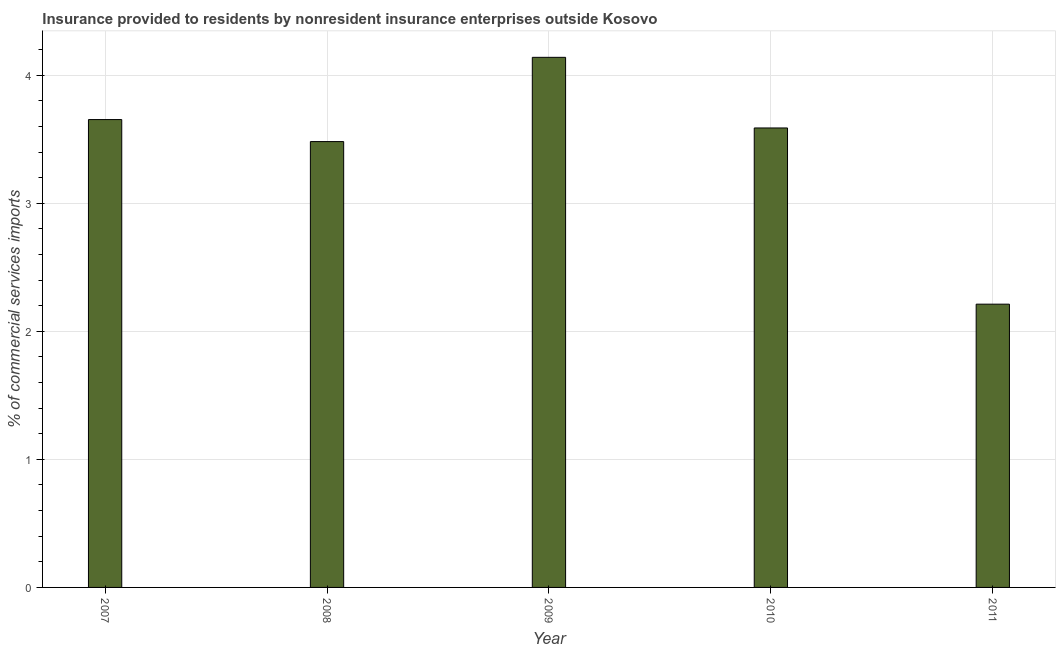Does the graph contain any zero values?
Offer a terse response. No. Does the graph contain grids?
Keep it short and to the point. Yes. What is the title of the graph?
Your response must be concise. Insurance provided to residents by nonresident insurance enterprises outside Kosovo. What is the label or title of the X-axis?
Make the answer very short. Year. What is the label or title of the Y-axis?
Offer a terse response. % of commercial services imports. What is the insurance provided by non-residents in 2010?
Your response must be concise. 3.59. Across all years, what is the maximum insurance provided by non-residents?
Keep it short and to the point. 4.14. Across all years, what is the minimum insurance provided by non-residents?
Ensure brevity in your answer.  2.21. What is the sum of the insurance provided by non-residents?
Your answer should be very brief. 17.07. What is the difference between the insurance provided by non-residents in 2008 and 2010?
Offer a very short reply. -0.11. What is the average insurance provided by non-residents per year?
Make the answer very short. 3.42. What is the median insurance provided by non-residents?
Make the answer very short. 3.59. What is the ratio of the insurance provided by non-residents in 2008 to that in 2010?
Ensure brevity in your answer.  0.97. What is the difference between the highest and the second highest insurance provided by non-residents?
Provide a short and direct response. 0.49. What is the difference between the highest and the lowest insurance provided by non-residents?
Keep it short and to the point. 1.93. In how many years, is the insurance provided by non-residents greater than the average insurance provided by non-residents taken over all years?
Ensure brevity in your answer.  4. How many bars are there?
Provide a succinct answer. 5. How many years are there in the graph?
Your answer should be compact. 5. What is the difference between two consecutive major ticks on the Y-axis?
Make the answer very short. 1. What is the % of commercial services imports in 2007?
Your answer should be very brief. 3.65. What is the % of commercial services imports of 2008?
Provide a succinct answer. 3.48. What is the % of commercial services imports in 2009?
Offer a very short reply. 4.14. What is the % of commercial services imports in 2010?
Your answer should be compact. 3.59. What is the % of commercial services imports of 2011?
Provide a short and direct response. 2.21. What is the difference between the % of commercial services imports in 2007 and 2008?
Offer a terse response. 0.17. What is the difference between the % of commercial services imports in 2007 and 2009?
Ensure brevity in your answer.  -0.49. What is the difference between the % of commercial services imports in 2007 and 2010?
Give a very brief answer. 0.07. What is the difference between the % of commercial services imports in 2007 and 2011?
Offer a very short reply. 1.44. What is the difference between the % of commercial services imports in 2008 and 2009?
Keep it short and to the point. -0.66. What is the difference between the % of commercial services imports in 2008 and 2010?
Your answer should be very brief. -0.11. What is the difference between the % of commercial services imports in 2008 and 2011?
Provide a short and direct response. 1.27. What is the difference between the % of commercial services imports in 2009 and 2010?
Offer a very short reply. 0.55. What is the difference between the % of commercial services imports in 2009 and 2011?
Your response must be concise. 1.93. What is the difference between the % of commercial services imports in 2010 and 2011?
Give a very brief answer. 1.38. What is the ratio of the % of commercial services imports in 2007 to that in 2008?
Make the answer very short. 1.05. What is the ratio of the % of commercial services imports in 2007 to that in 2009?
Your answer should be compact. 0.88. What is the ratio of the % of commercial services imports in 2007 to that in 2010?
Make the answer very short. 1.02. What is the ratio of the % of commercial services imports in 2007 to that in 2011?
Offer a very short reply. 1.65. What is the ratio of the % of commercial services imports in 2008 to that in 2009?
Offer a terse response. 0.84. What is the ratio of the % of commercial services imports in 2008 to that in 2011?
Your answer should be compact. 1.57. What is the ratio of the % of commercial services imports in 2009 to that in 2010?
Make the answer very short. 1.15. What is the ratio of the % of commercial services imports in 2009 to that in 2011?
Your response must be concise. 1.87. What is the ratio of the % of commercial services imports in 2010 to that in 2011?
Ensure brevity in your answer.  1.62. 